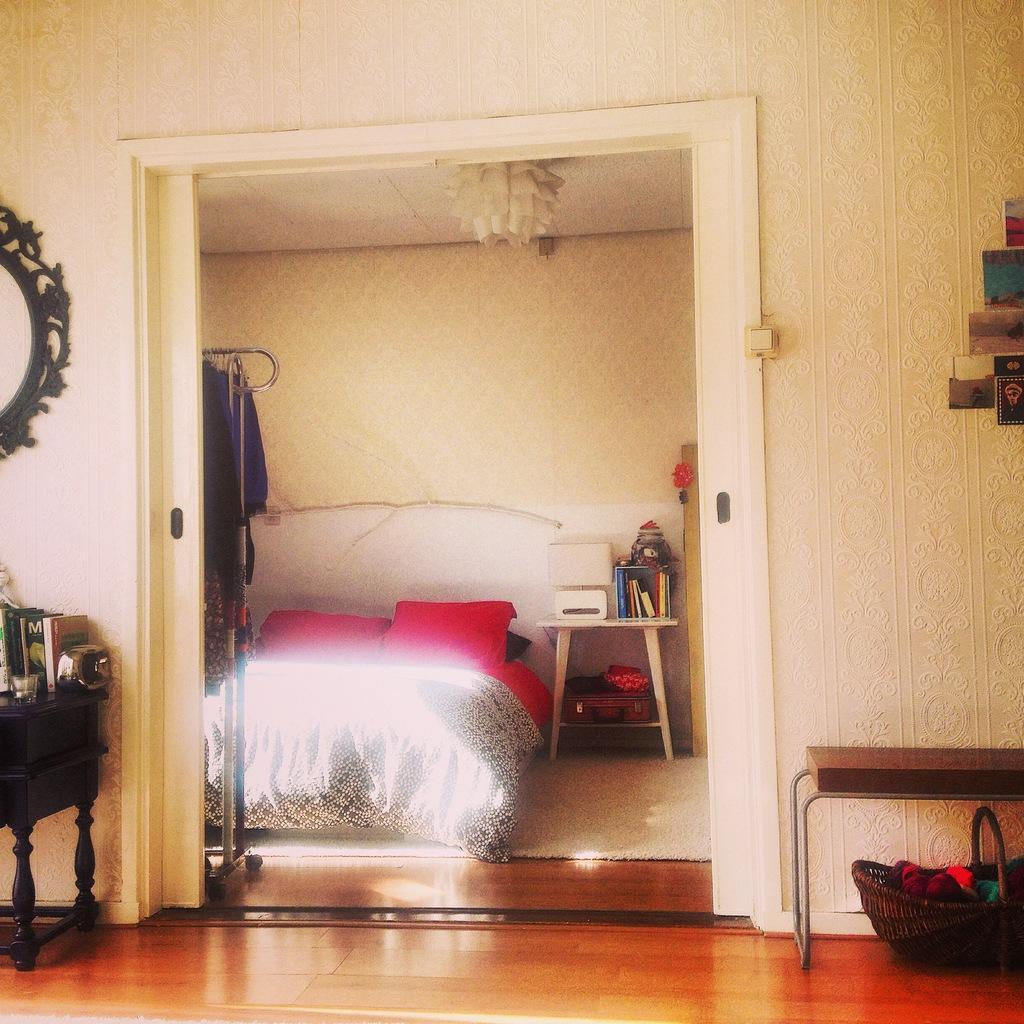In one or two sentences, can you explain what this image depicts? This picture describes about inside view of a room, on the right side of the image we can see a basket, a table and posters on the wall, on the left side of the image we can see few books and a mirror, in the background we can see light and pillows on the bed, beside the bed we can see books and other things on the table. 